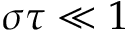<formula> <loc_0><loc_0><loc_500><loc_500>\sigma \tau \ll 1</formula> 